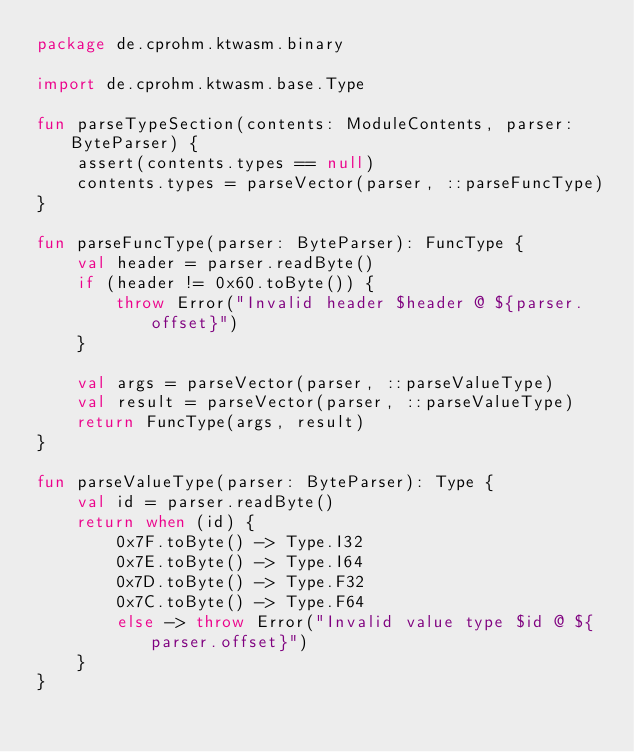Convert code to text. <code><loc_0><loc_0><loc_500><loc_500><_Kotlin_>package de.cprohm.ktwasm.binary

import de.cprohm.ktwasm.base.Type

fun parseTypeSection(contents: ModuleContents, parser: ByteParser) {
    assert(contents.types == null)
    contents.types = parseVector(parser, ::parseFuncType)
}

fun parseFuncType(parser: ByteParser): FuncType {
    val header = parser.readByte()
    if (header != 0x60.toByte()) {
        throw Error("Invalid header $header @ ${parser.offset}")
    }

    val args = parseVector(parser, ::parseValueType)
    val result = parseVector(parser, ::parseValueType)
    return FuncType(args, result)
}

fun parseValueType(parser: ByteParser): Type {
    val id = parser.readByte()
    return when (id) {
        0x7F.toByte() -> Type.I32
        0x7E.toByte() -> Type.I64
        0x7D.toByte() -> Type.F32
        0x7C.toByte() -> Type.F64
        else -> throw Error("Invalid value type $id @ ${parser.offset}")
    }
}
</code> 